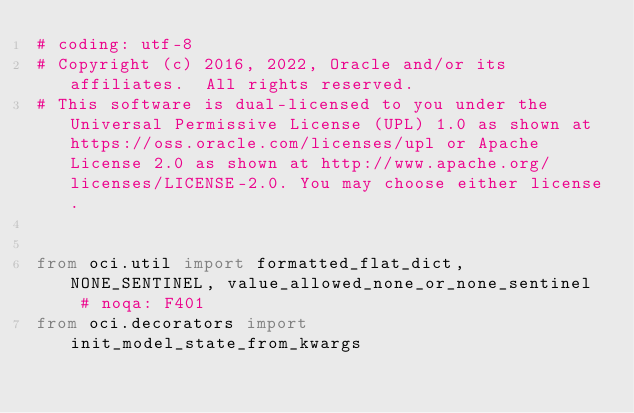Convert code to text. <code><loc_0><loc_0><loc_500><loc_500><_Python_># coding: utf-8
# Copyright (c) 2016, 2022, Oracle and/or its affiliates.  All rights reserved.
# This software is dual-licensed to you under the Universal Permissive License (UPL) 1.0 as shown at https://oss.oracle.com/licenses/upl or Apache License 2.0 as shown at http://www.apache.org/licenses/LICENSE-2.0. You may choose either license.


from oci.util import formatted_flat_dict, NONE_SENTINEL, value_allowed_none_or_none_sentinel  # noqa: F401
from oci.decorators import init_model_state_from_kwargs

</code> 